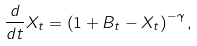Convert formula to latex. <formula><loc_0><loc_0><loc_500><loc_500>\frac { d } { d t } X _ { t } = \left ( 1 + B _ { t } - X _ { t } \right ) ^ { - \gamma } ,</formula> 